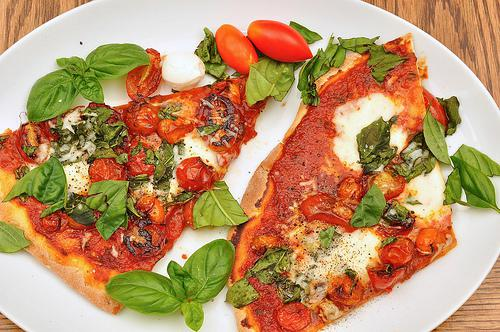Question: how many pizza slices are in the photo?
Choices:
A. 6.
B. 8.
C. 9.
D. 3.
Answer with the letter. Answer: D Question: who is the subject of this photo?
Choices:
A. Pizza.
B. Salad.
C. Hamburger.
D. Hotdog.
Answer with the letter. Answer: A 